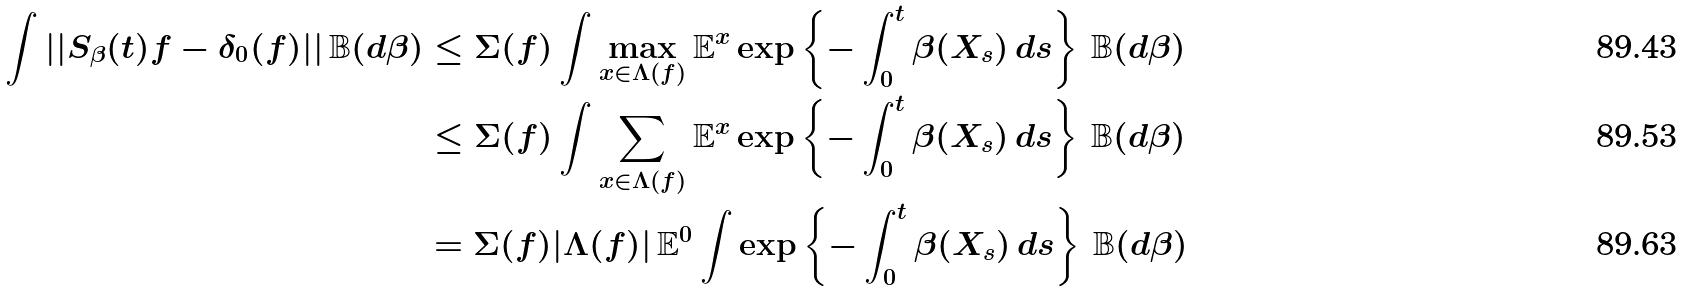<formula> <loc_0><loc_0><loc_500><loc_500>\int | | S _ { \beta } ( t ) f - \delta _ { 0 } ( f ) | | \, \mathbb { B } ( d \beta ) & \leq \Sigma ( f ) \int \max _ { x \in \Lambda ( f ) } \mathbb { E } ^ { x } \exp \left \{ - \int _ { 0 } ^ { t } \beta ( X _ { s } ) \, d s \right \} \, \mathbb { B } ( d \beta ) \\ & \leq \Sigma ( f ) \int \sum _ { x \in \Lambda ( f ) } \mathbb { E } ^ { x } \exp \left \{ - \int _ { 0 } ^ { t } \beta ( X _ { s } ) \, d s \right \} \, \mathbb { B } ( d \beta ) \\ & = \Sigma ( f ) | \Lambda ( f ) | \, \mathbb { E } ^ { 0 } \int \exp \left \{ - \int _ { 0 } ^ { t } \beta ( X _ { s } ) \, d s \right \} \, \mathbb { B } ( d \beta )</formula> 